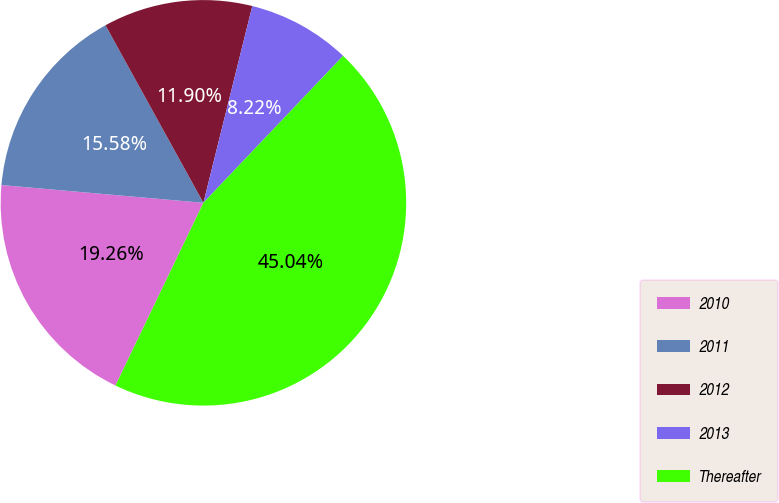Convert chart to OTSL. <chart><loc_0><loc_0><loc_500><loc_500><pie_chart><fcel>2010<fcel>2011<fcel>2012<fcel>2013<fcel>Thereafter<nl><fcel>19.26%<fcel>15.58%<fcel>11.9%<fcel>8.22%<fcel>45.04%<nl></chart> 